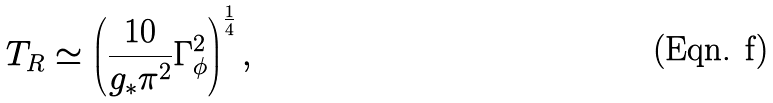Convert formula to latex. <formula><loc_0><loc_0><loc_500><loc_500>T _ { R } \simeq \left ( \frac { 1 0 } { g _ { * } \pi ^ { 2 } } \Gamma _ { \phi } ^ { 2 } \right ) ^ { \frac { 1 } { 4 } } ,</formula> 